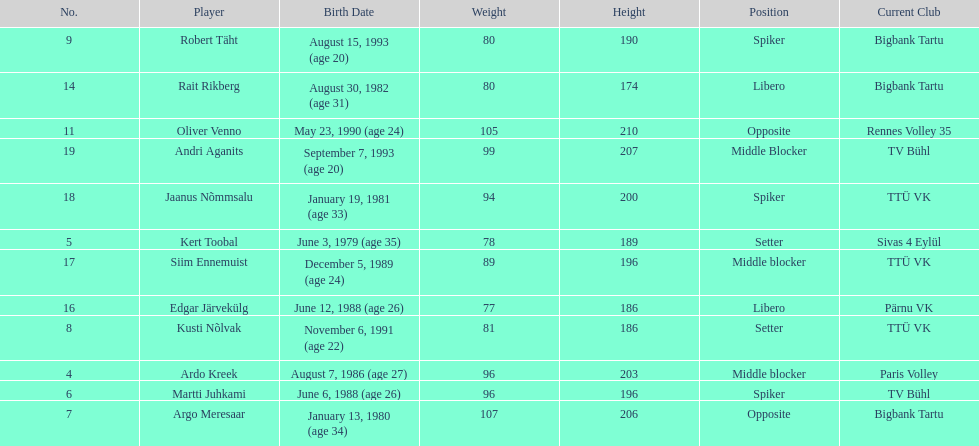Which players played the same position as ardo kreek? Siim Ennemuist, Andri Aganits. 